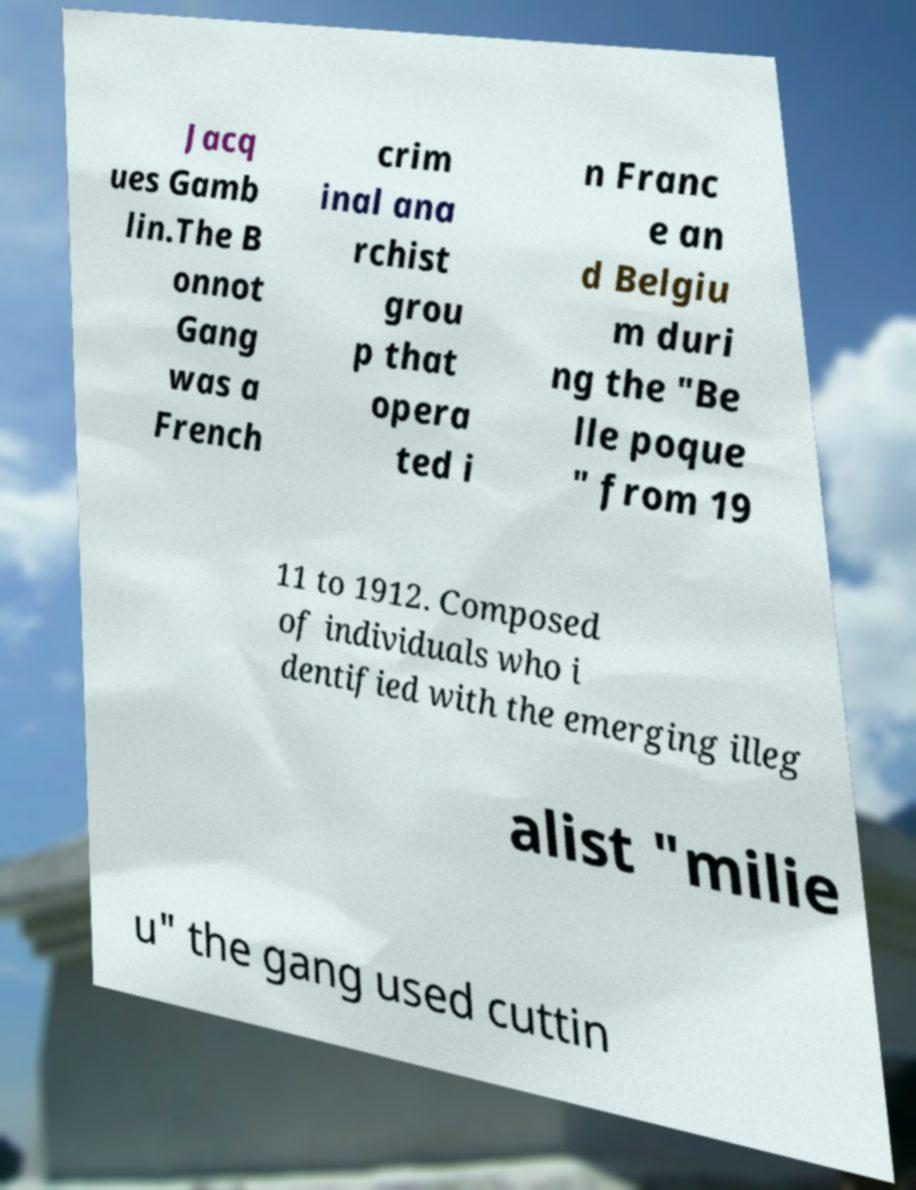What messages or text are displayed in this image? I need them in a readable, typed format. Jacq ues Gamb lin.The B onnot Gang was a French crim inal ana rchist grou p that opera ted i n Franc e an d Belgiu m duri ng the "Be lle poque " from 19 11 to 1912. Composed of individuals who i dentified with the emerging illeg alist "milie u" the gang used cuttin 